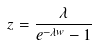Convert formula to latex. <formula><loc_0><loc_0><loc_500><loc_500>z = \frac { \lambda } { e ^ { - \lambda w } - 1 }</formula> 